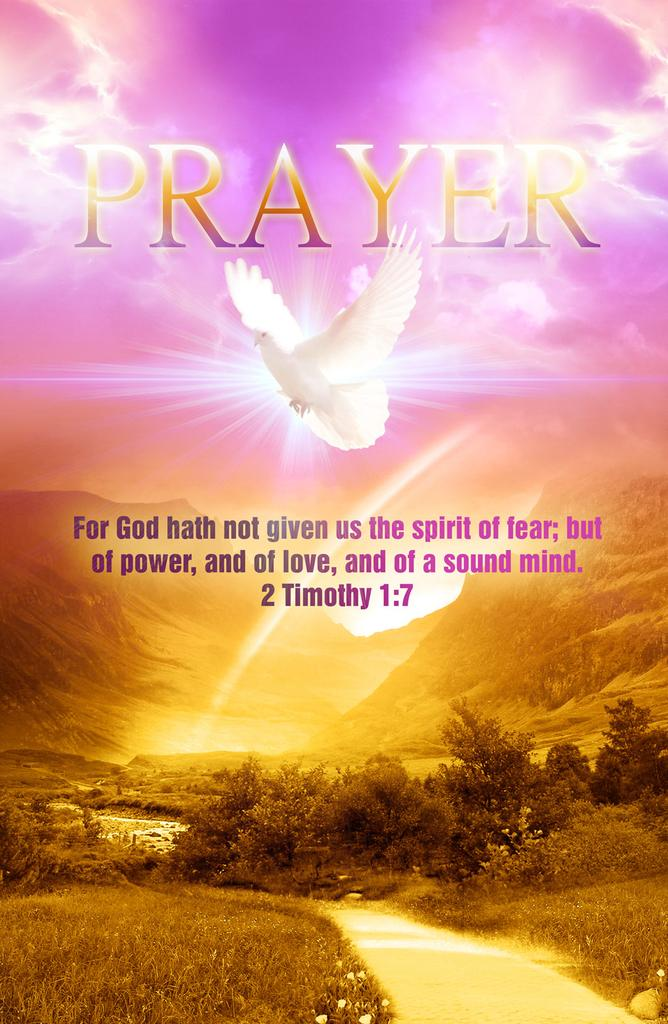<image>
Describe the image concisely. A poster that says "prayer" along with a bible verse and a dove in the purple sky. 